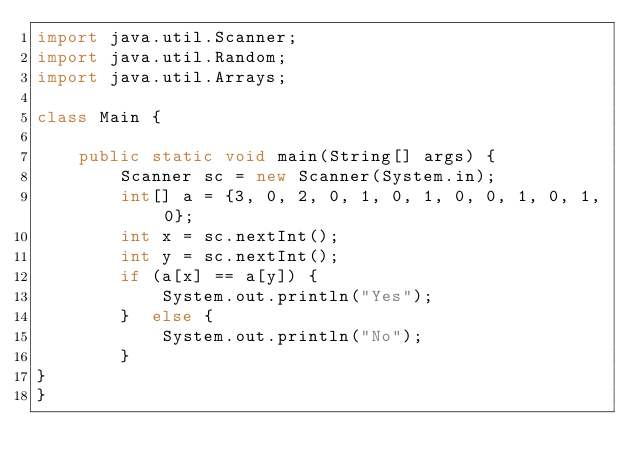<code> <loc_0><loc_0><loc_500><loc_500><_Java_>import java.util.Scanner;
import java.util.Random;
import java.util.Arrays;

class Main {
	
	public static void main(String[] args) {
		Scanner sc = new Scanner(System.in);
		int[] a = {3, 0, 2, 0, 1, 0, 1, 0, 0, 1, 0, 1, 0};
		int x = sc.nextInt();
    	int y = sc.nextInt();
    	if (a[x] == a[y]) {
    		System.out.println("Yes");
    	}  else {
    		System.out.println("No");
    	}
}
}</code> 